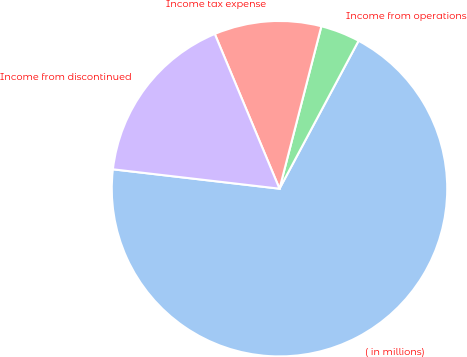Convert chart. <chart><loc_0><loc_0><loc_500><loc_500><pie_chart><fcel>( in millions)<fcel>Income from operations<fcel>Income tax expense<fcel>Income from discontinued<nl><fcel>69.03%<fcel>3.8%<fcel>10.32%<fcel>16.85%<nl></chart> 